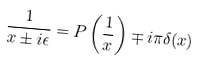<formula> <loc_0><loc_0><loc_500><loc_500>\frac { 1 } { x \pm i \epsilon } = P \left ( \frac { 1 } { x } \right ) \mp i \pi \delta ( x )</formula> 